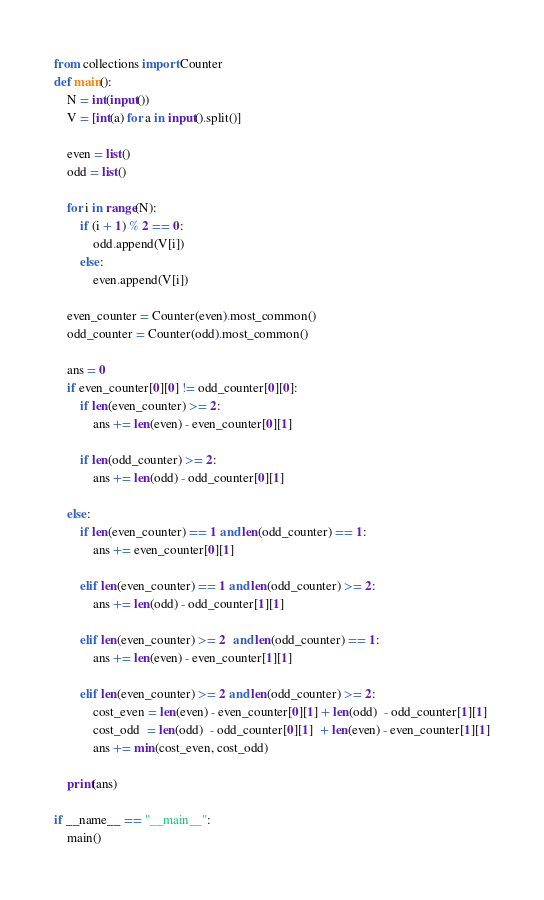<code> <loc_0><loc_0><loc_500><loc_500><_Python_>from collections import Counter
def main():
    N = int(input())
    V = [int(a) for a in input().split()]
    
    even = list()
    odd = list()

    for i in range(N):
        if (i + 1) % 2 == 0:
            odd.append(V[i])
        else:
            even.append(V[i])

    even_counter = Counter(even).most_common()
    odd_counter = Counter(odd).most_common()

    ans = 0
    if even_counter[0][0] != odd_counter[0][0]:
        if len(even_counter) >= 2:
            ans += len(even) - even_counter[0][1]

        if len(odd_counter) >= 2:
            ans += len(odd) - odd_counter[0][1]

    else:
        if len(even_counter) == 1 and len(odd_counter) == 1:
            ans += even_counter[0][1]

        elif len(even_counter) == 1 and len(odd_counter) >= 2:
            ans += len(odd) - odd_counter[1][1]

        elif len(even_counter) >= 2  and len(odd_counter) == 1:
            ans += len(even) - even_counter[1][1]

        elif len(even_counter) >= 2 and len(odd_counter) >= 2:
            cost_even = len(even) - even_counter[0][1] + len(odd)  - odd_counter[1][1]
            cost_odd  = len(odd)  - odd_counter[0][1]  + len(even) - even_counter[1][1]
            ans += min(cost_even, cost_odd)

    print(ans)

if __name__ == "__main__":
    main()</code> 